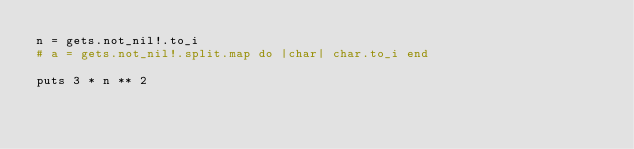<code> <loc_0><loc_0><loc_500><loc_500><_Crystal_>n = gets.not_nil!.to_i
# a = gets.not_nil!.split.map do |char| char.to_i end

puts 3 * n ** 2</code> 